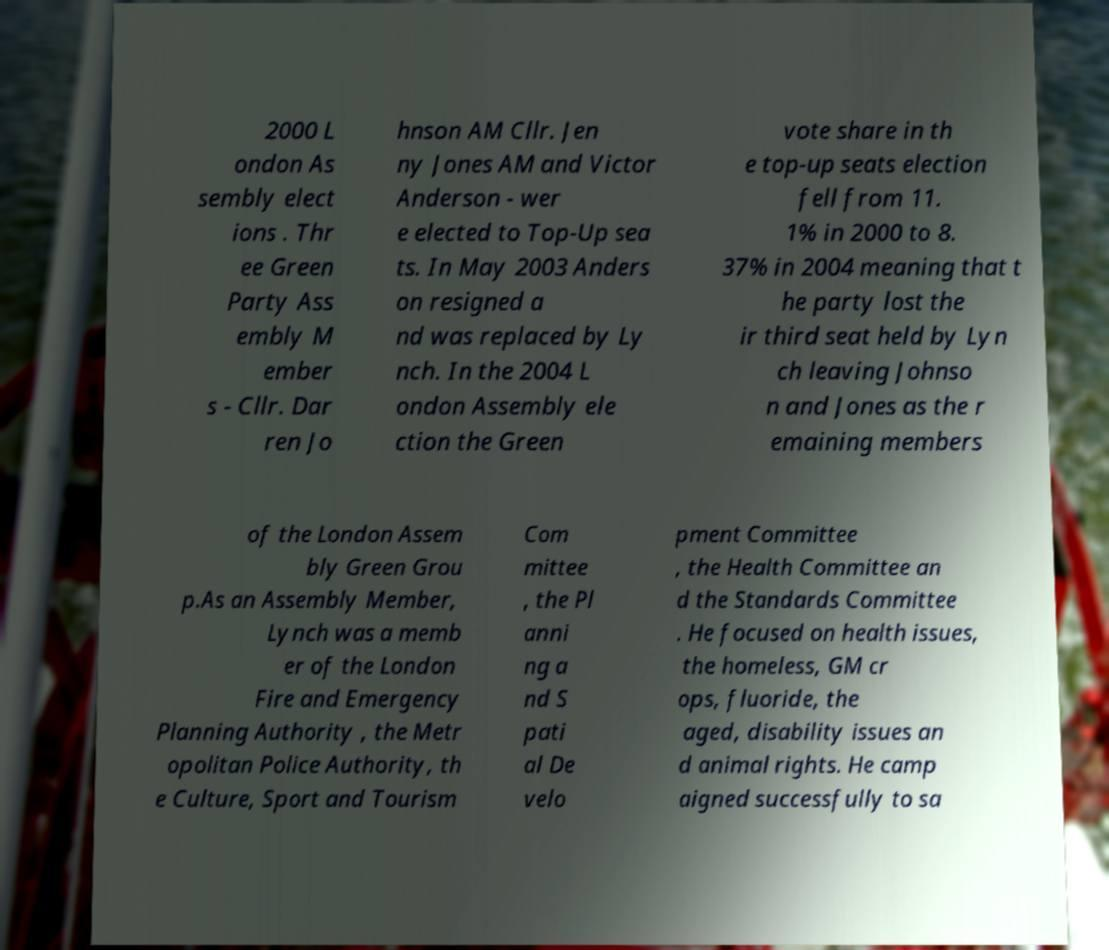Could you assist in decoding the text presented in this image and type it out clearly? 2000 L ondon As sembly elect ions . Thr ee Green Party Ass embly M ember s - Cllr. Dar ren Jo hnson AM Cllr. Jen ny Jones AM and Victor Anderson - wer e elected to Top-Up sea ts. In May 2003 Anders on resigned a nd was replaced by Ly nch. In the 2004 L ondon Assembly ele ction the Green vote share in th e top-up seats election fell from 11. 1% in 2000 to 8. 37% in 2004 meaning that t he party lost the ir third seat held by Lyn ch leaving Johnso n and Jones as the r emaining members of the London Assem bly Green Grou p.As an Assembly Member, Lynch was a memb er of the London Fire and Emergency Planning Authority , the Metr opolitan Police Authority, th e Culture, Sport and Tourism Com mittee , the Pl anni ng a nd S pati al De velo pment Committee , the Health Committee an d the Standards Committee . He focused on health issues, the homeless, GM cr ops, fluoride, the aged, disability issues an d animal rights. He camp aigned successfully to sa 